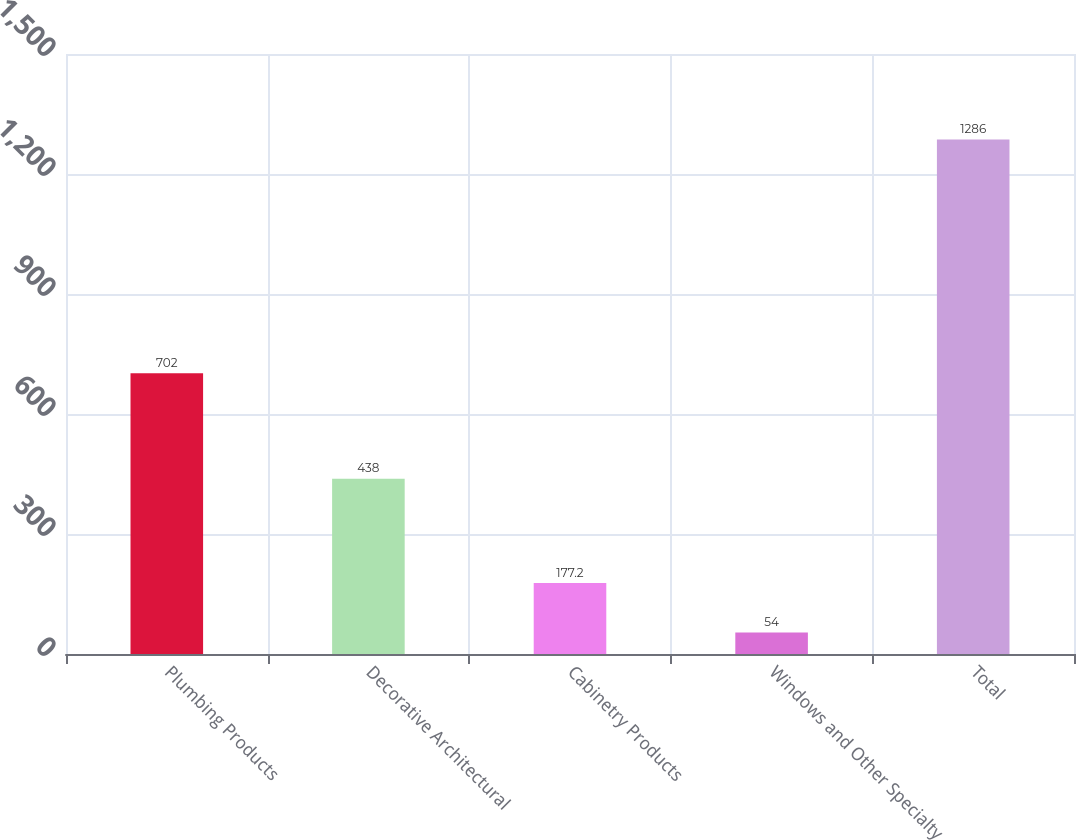<chart> <loc_0><loc_0><loc_500><loc_500><bar_chart><fcel>Plumbing Products<fcel>Decorative Architectural<fcel>Cabinetry Products<fcel>Windows and Other Specialty<fcel>Total<nl><fcel>702<fcel>438<fcel>177.2<fcel>54<fcel>1286<nl></chart> 